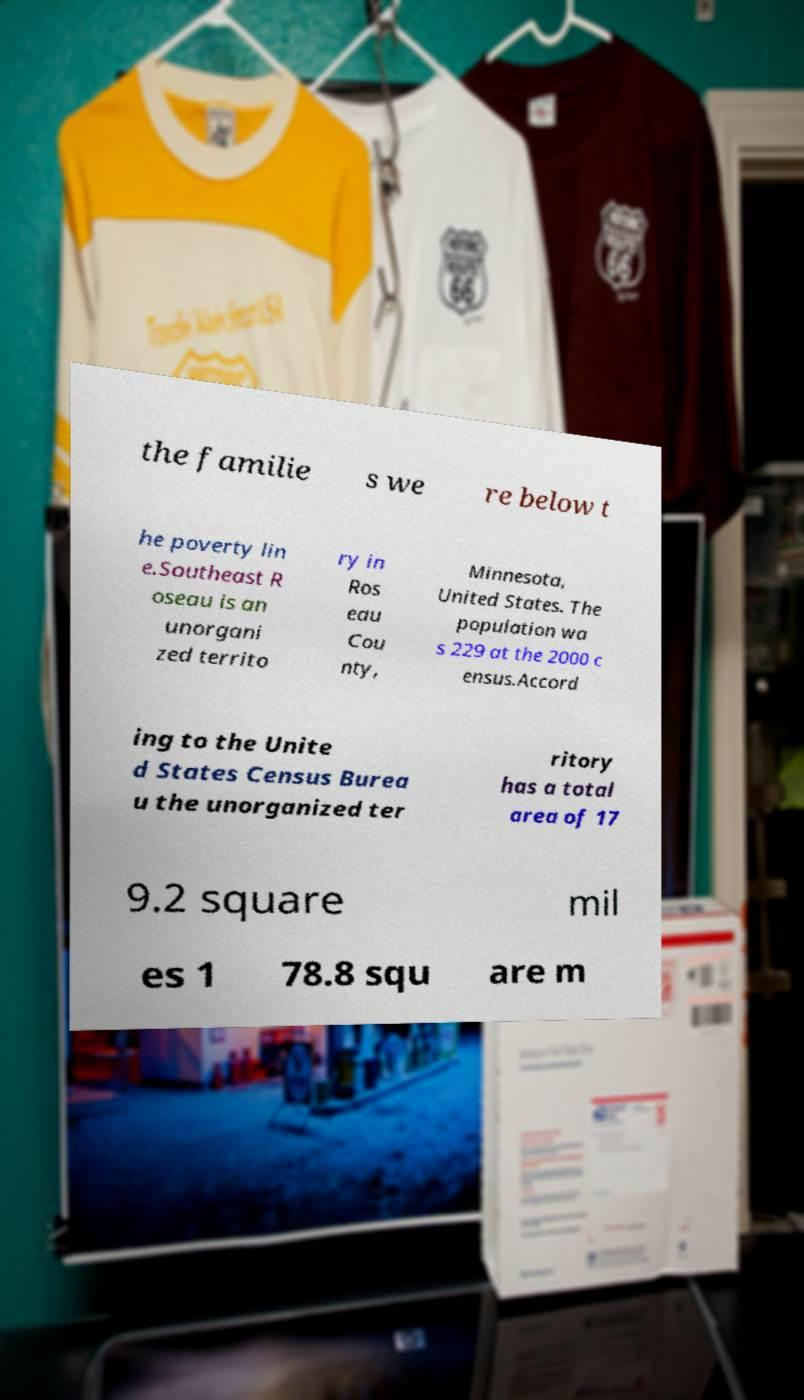Please read and relay the text visible in this image. What does it say? the familie s we re below t he poverty lin e.Southeast R oseau is an unorgani zed territo ry in Ros eau Cou nty, Minnesota, United States. The population wa s 229 at the 2000 c ensus.Accord ing to the Unite d States Census Burea u the unorganized ter ritory has a total area of 17 9.2 square mil es 1 78.8 squ are m 